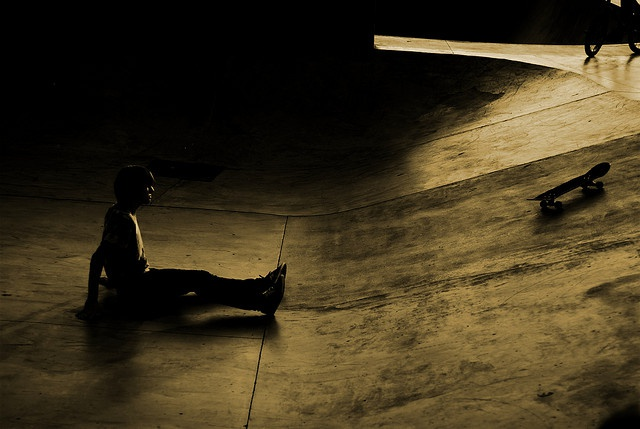Describe the objects in this image and their specific colors. I can see people in black, olive, and tan tones, bicycle in black, tan, and olive tones, and skateboard in black, olive, and gray tones in this image. 